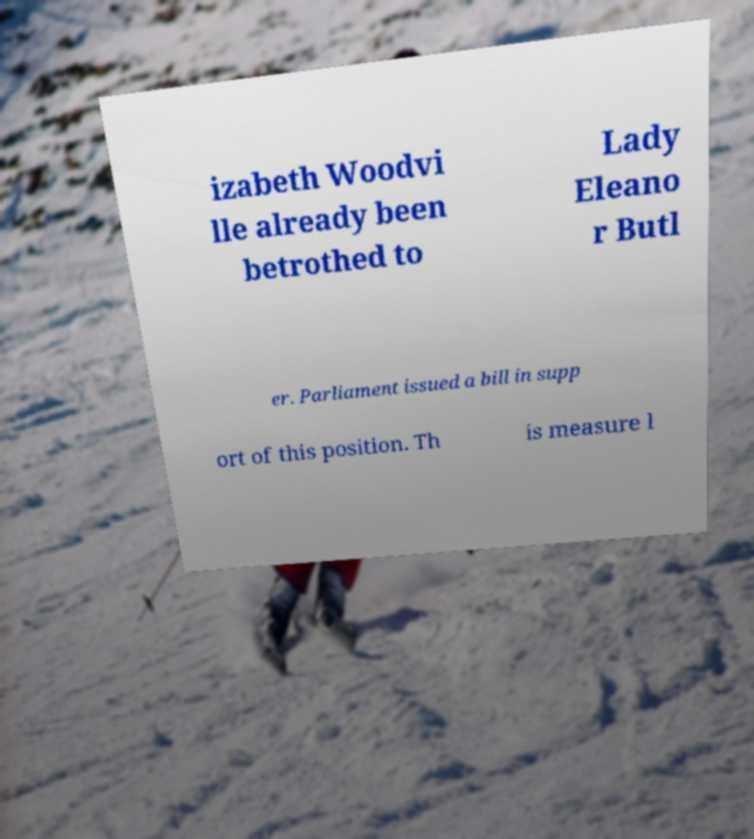For documentation purposes, I need the text within this image transcribed. Could you provide that? izabeth Woodvi lle already been betrothed to Lady Eleano r Butl er. Parliament issued a bill in supp ort of this position. Th is measure l 